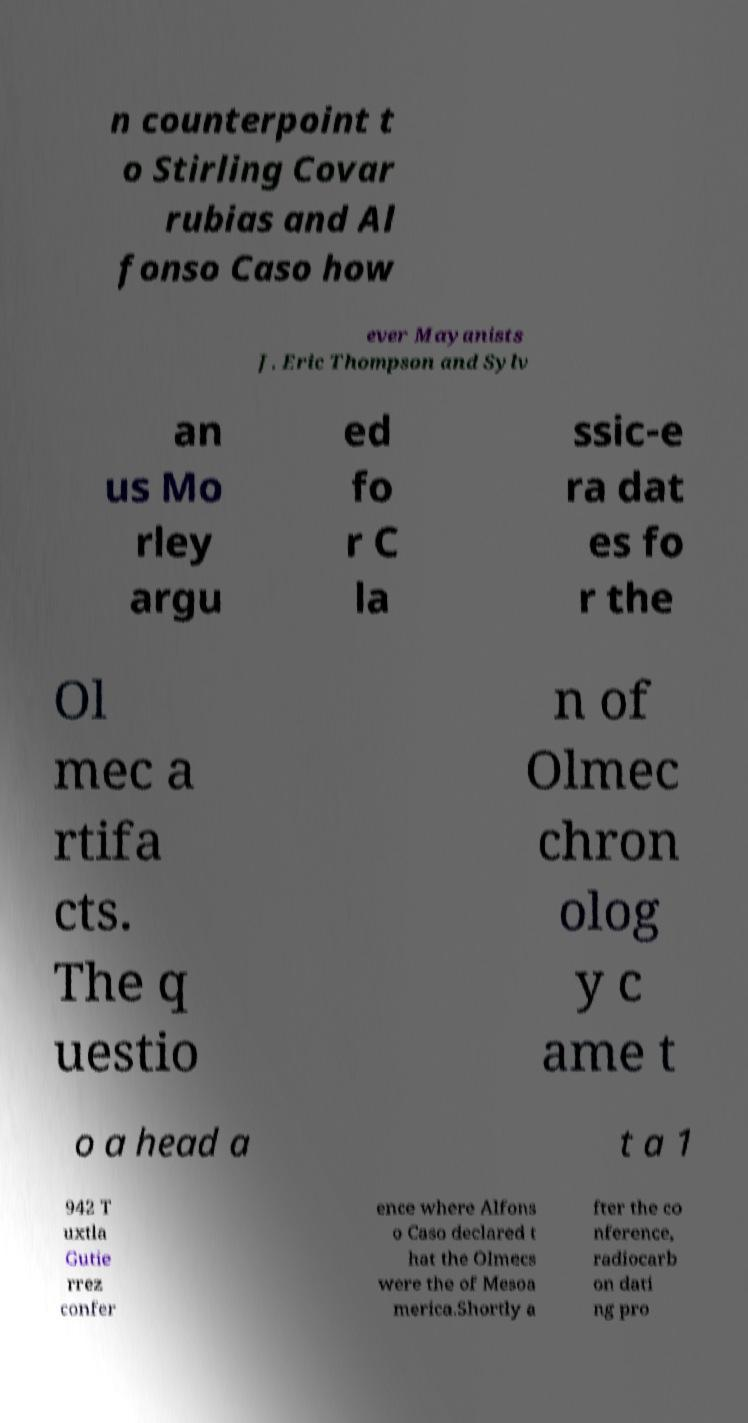There's text embedded in this image that I need extracted. Can you transcribe it verbatim? n counterpoint t o Stirling Covar rubias and Al fonso Caso how ever Mayanists J. Eric Thompson and Sylv an us Mo rley argu ed fo r C la ssic-e ra dat es fo r the Ol mec a rtifa cts. The q uestio n of Olmec chron olog y c ame t o a head a t a 1 942 T uxtla Gutie rrez confer ence where Alfons o Caso declared t hat the Olmecs were the of Mesoa merica.Shortly a fter the co nference, radiocarb on dati ng pro 